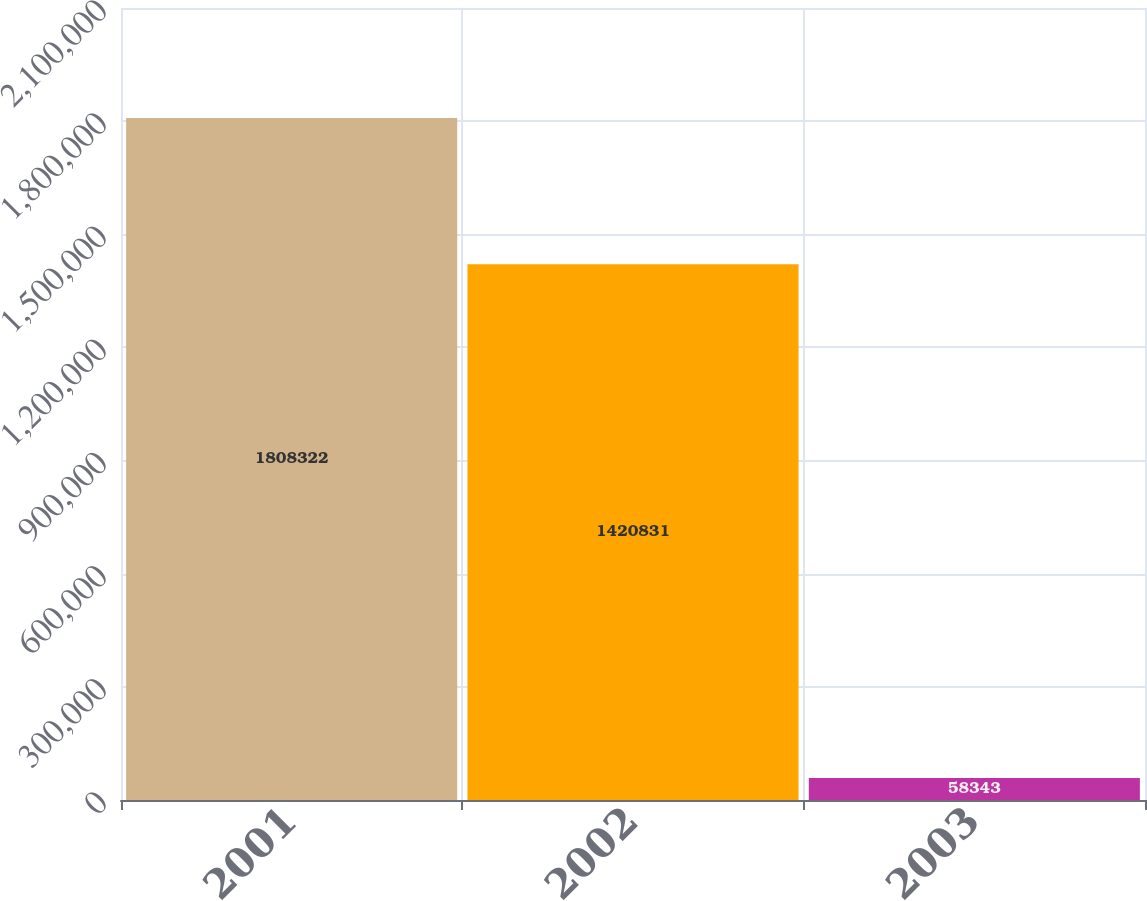Convert chart to OTSL. <chart><loc_0><loc_0><loc_500><loc_500><bar_chart><fcel>2001<fcel>2002<fcel>2003<nl><fcel>1.80832e+06<fcel>1.42083e+06<fcel>58343<nl></chart> 